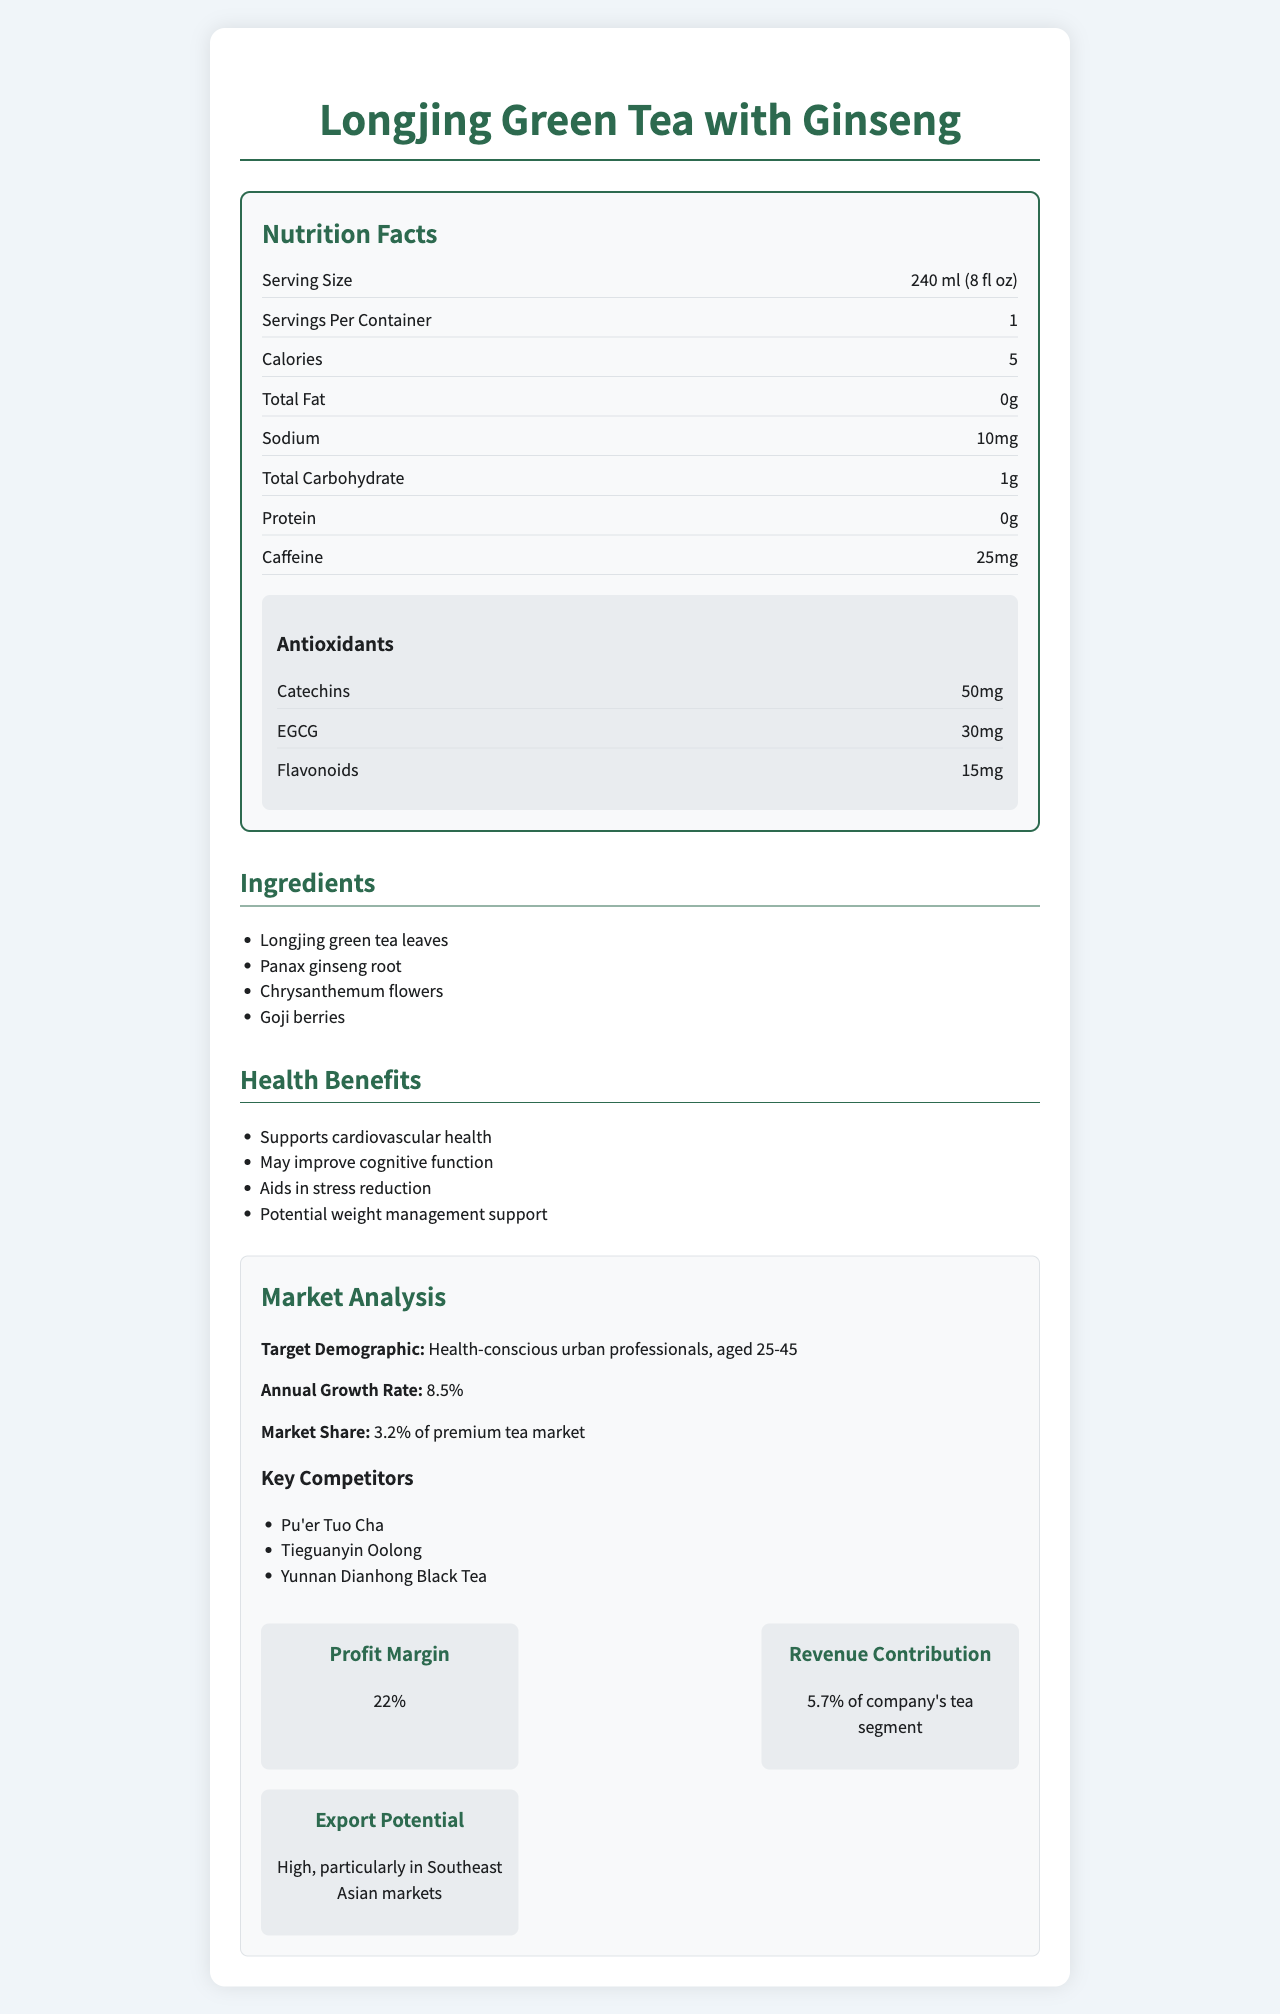what is the serving size for Longjing Green Tea with Ginseng? The serving size is clearly stated in the nutrition label section as 240 ml (8 fl oz).
Answer: 240 ml (8 fl oz) what are the main ingredients of Longjing Green Tea with Ginseng? The ingredients are listed explicitly under the ingredients section.
Answer: Longjing green tea leaves, Panax ginseng root, Chrysanthemum flowers, Goji berries what is the amount of caffeine content per serving? The caffeine content is listed in the nutrition label under the specific item "Caffeine".
Answer: 25 mg list the antioxidants found in the tea and their amounts. The antioxidants and their amounts are specified in the "Antioxidants" section of the nutrition label.
Answer: Catechins: 50 mg, EGCG: 30 mg, Flavonoids: 15 mg how much sodium is present in one serving of the tea? The sodium content per serving is listed as 10 mg in the nutrition label.
Answer: 10 mg which antioxidant has the highest presence in the tea? A. Catechins B. EGCG C. Flavonoids Catechins is listed as having 50 mg, which is the highest among the antioxidants mentioned.
Answer: A. Catechins what is the annual growth rate of the market for this tea? The annual growth rate is given in the market analysis section as 8.5%.
Answer: 8.5% who are the key competitors mentioned in the document? A. Pu'er Tuo Cha B. Tieguanyin Oolong C. Yunnan Dianhong Black Tea D. All of the above All three competitors are listed in the market analysis section as key competitors.
Answer: D. All of the above does the tea contain any protein? The protein content is listed as 0 in the nutrition label.
Answer: No summarize the overall health benefits of this herbal tea. The health benefits are comprehensively listed under the "health benefits" section and include benefits related to cardiovascular health, cognitive function, stress reduction, and weight management.
Answer: The herbal tea supports cardiovascular health, may improve cognitive function, aids in stress reduction, and potentially supports weight management. what is the origin of Longjing Green Tea with Ginseng? This is stated in the document under the origin section.
Answer: Hangzhou, Zhejiang Province, China how should the tea be brewed according to the document? The brewing instructions state to steep the tea for 2-3 minutes in 80°C (176°F) water.
Answer: Steep for 2-3 minutes in 80°C (176°F) water what percentage of the company’s tea segment revenue does this product contribute? The revenue contribution is listed in the financial indicators section as contributing 5.7% of the company’s tea segment.
Answer: 5.7% what is the calorie content per serving of the tea? The calorie content is clearly indicated in the nutrition label as 5 calories per serving.
Answer: 5 calories what is the certification authority mentioned in the document? The certification is stated in the document under the certification section.
Answer: China Green Food Development Center does the tea aid in any form of stress management? One of the health benefits mentioned is that the tea aids in stress reduction.
Answer: Yes what are the vitamins and minerals present in the tea? The vitamins and minerals are listed in the nutrition label.
Answer: Vitamin C: 2%, Manganese: 5%, Potassium: 1% what is the market share of Longjing Green Tea with Ginseng in the premium tea market? The market share is given in the market analysis section as 3.2%.
Answer: 3.2% what is the potential for exporting this tea to Southeast Asian markets? The export potential is stated as high, particularly in Southeast Asian markets, in the financial indicators section.
Answer: High what is the percentage of vitamin B12 in the tea? The document does not provide any information about the presence or percentage of vitamin B12 in the tea.
Answer: Not enough information 